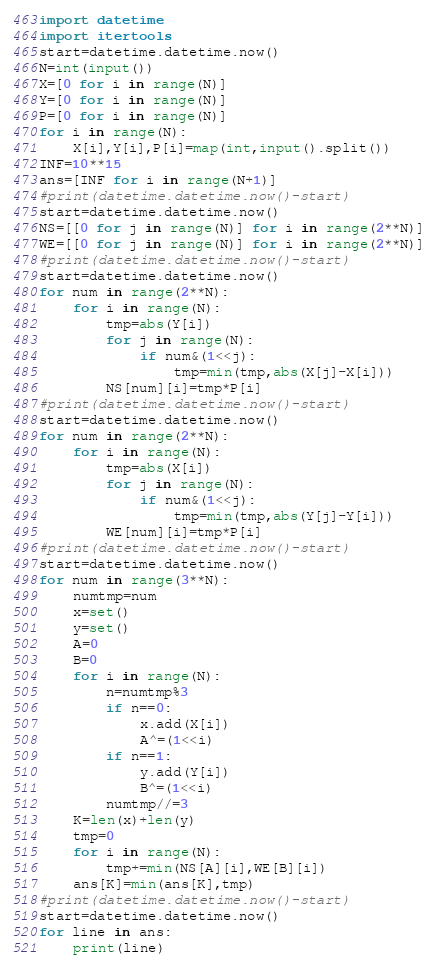Convert code to text. <code><loc_0><loc_0><loc_500><loc_500><_Python_>import datetime
import itertools
start=datetime.datetime.now()
N=int(input())
X=[0 for i in range(N)]
Y=[0 for i in range(N)]
P=[0 for i in range(N)]
for i in range(N):
    X[i],Y[i],P[i]=map(int,input().split())
INF=10**15
ans=[INF for i in range(N+1)]
#print(datetime.datetime.now()-start)
start=datetime.datetime.now()
NS=[[0 for j in range(N)] for i in range(2**N)]
WE=[[0 for j in range(N)] for i in range(2**N)]
#print(datetime.datetime.now()-start)
start=datetime.datetime.now()
for num in range(2**N):
    for i in range(N):
        tmp=abs(Y[i])
        for j in range(N):
            if num&(1<<j):
                tmp=min(tmp,abs(X[j]-X[i]))
        NS[num][i]=tmp*P[i]
#print(datetime.datetime.now()-start)
start=datetime.datetime.now()
for num in range(2**N):
    for i in range(N):
        tmp=abs(X[i])
        for j in range(N):
            if num&(1<<j):
                tmp=min(tmp,abs(Y[j]-Y[i]))
        WE[num][i]=tmp*P[i]
#print(datetime.datetime.now()-start)
start=datetime.datetime.now()
for num in range(3**N):
	numtmp=num
	x=set()
	y=set()
	A=0
	B=0
	for i in range(N):
	    n=numtmp%3
	    if n==0:
	        x.add(X[i])
	        A^=(1<<i)
	    if n==1:
	        y.add(Y[i])
	        B^=(1<<i)
	    numtmp//=3
	K=len(x)+len(y)
	tmp=0
	for i in range(N):
	    tmp+=min(NS[A][i],WE[B][i])
	ans[K]=min(ans[K],tmp)
#print(datetime.datetime.now()-start)
start=datetime.datetime.now()
for line in ans:
    print(line)</code> 